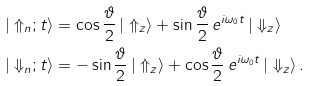<formula> <loc_0><loc_0><loc_500><loc_500>| \Uparrow _ { n } ; t \rangle & = \cos \frac { \vartheta } { 2 } \, | \Uparrow _ { z } \rangle + \sin \frac { \vartheta } { 2 } \, e ^ { i \omega _ { 0 } t } \, | \Downarrow _ { z } \rangle \\ | \Downarrow _ { n } ; t \rangle & = - \sin \frac { \vartheta } { 2 } \, | \Uparrow _ { z } \rangle + \cos \frac { \vartheta } { 2 } \, e ^ { i \omega _ { 0 } t } \, | \Downarrow _ { z } \rangle \, .</formula> 